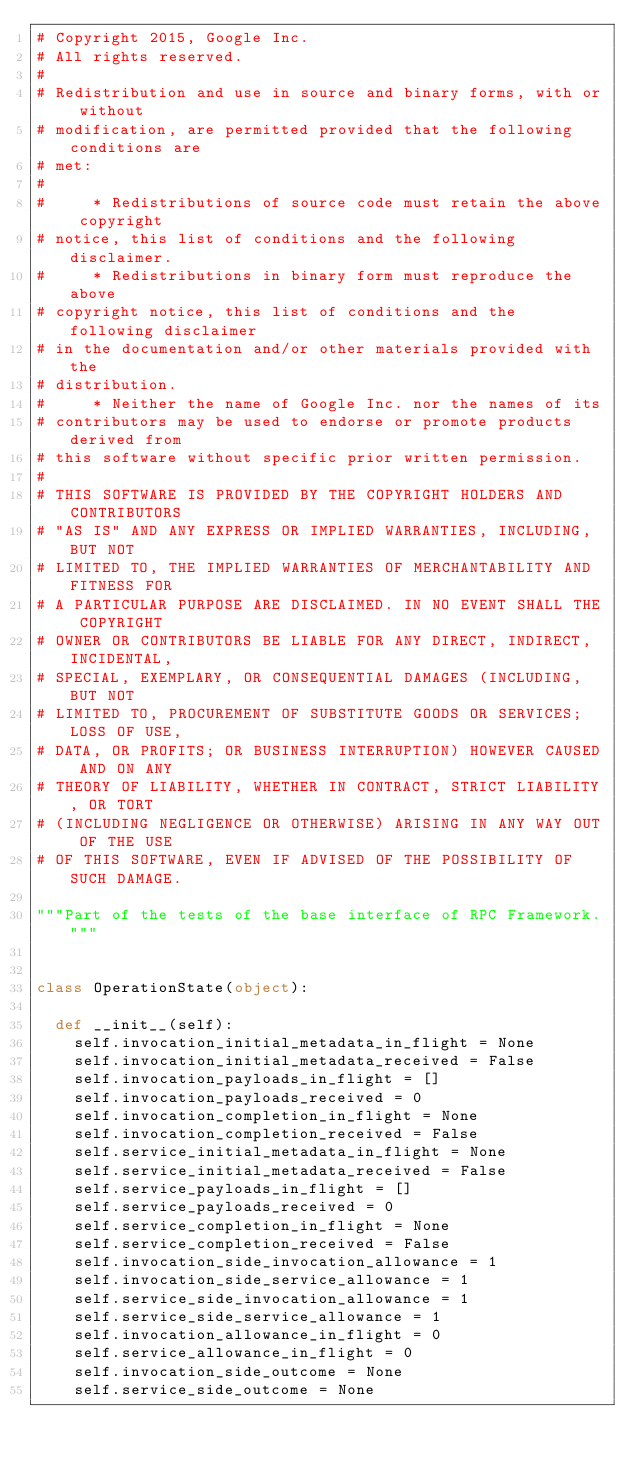Convert code to text. <code><loc_0><loc_0><loc_500><loc_500><_Python_># Copyright 2015, Google Inc.
# All rights reserved.
#
# Redistribution and use in source and binary forms, with or without
# modification, are permitted provided that the following conditions are
# met:
#
#     * Redistributions of source code must retain the above copyright
# notice, this list of conditions and the following disclaimer.
#     * Redistributions in binary form must reproduce the above
# copyright notice, this list of conditions and the following disclaimer
# in the documentation and/or other materials provided with the
# distribution.
#     * Neither the name of Google Inc. nor the names of its
# contributors may be used to endorse or promote products derived from
# this software without specific prior written permission.
#
# THIS SOFTWARE IS PROVIDED BY THE COPYRIGHT HOLDERS AND CONTRIBUTORS
# "AS IS" AND ANY EXPRESS OR IMPLIED WARRANTIES, INCLUDING, BUT NOT
# LIMITED TO, THE IMPLIED WARRANTIES OF MERCHANTABILITY AND FITNESS FOR
# A PARTICULAR PURPOSE ARE DISCLAIMED. IN NO EVENT SHALL THE COPYRIGHT
# OWNER OR CONTRIBUTORS BE LIABLE FOR ANY DIRECT, INDIRECT, INCIDENTAL,
# SPECIAL, EXEMPLARY, OR CONSEQUENTIAL DAMAGES (INCLUDING, BUT NOT
# LIMITED TO, PROCUREMENT OF SUBSTITUTE GOODS OR SERVICES; LOSS OF USE,
# DATA, OR PROFITS; OR BUSINESS INTERRUPTION) HOWEVER CAUSED AND ON ANY
# THEORY OF LIABILITY, WHETHER IN CONTRACT, STRICT LIABILITY, OR TORT
# (INCLUDING NEGLIGENCE OR OTHERWISE) ARISING IN ANY WAY OUT OF THE USE
# OF THIS SOFTWARE, EVEN IF ADVISED OF THE POSSIBILITY OF SUCH DAMAGE.

"""Part of the tests of the base interface of RPC Framework."""


class OperationState(object):

  def __init__(self):
    self.invocation_initial_metadata_in_flight = None
    self.invocation_initial_metadata_received = False
    self.invocation_payloads_in_flight = []
    self.invocation_payloads_received = 0
    self.invocation_completion_in_flight = None
    self.invocation_completion_received = False
    self.service_initial_metadata_in_flight = None
    self.service_initial_metadata_received = False
    self.service_payloads_in_flight = []
    self.service_payloads_received = 0
    self.service_completion_in_flight = None
    self.service_completion_received = False
    self.invocation_side_invocation_allowance = 1
    self.invocation_side_service_allowance = 1
    self.service_side_invocation_allowance = 1
    self.service_side_service_allowance = 1
    self.invocation_allowance_in_flight = 0
    self.service_allowance_in_flight = 0
    self.invocation_side_outcome = None
    self.service_side_outcome = None
</code> 